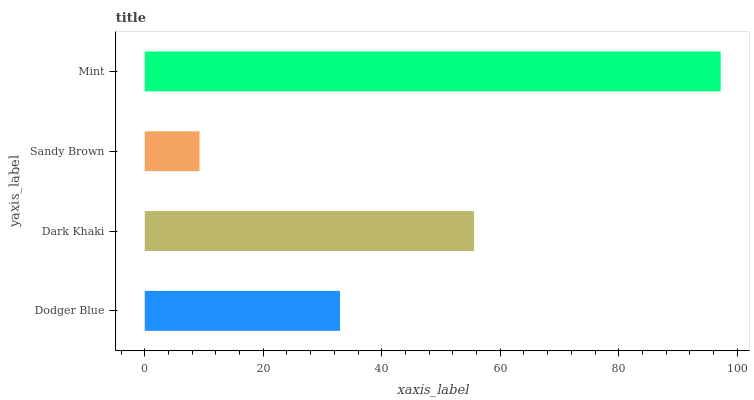Is Sandy Brown the minimum?
Answer yes or no. Yes. Is Mint the maximum?
Answer yes or no. Yes. Is Dark Khaki the minimum?
Answer yes or no. No. Is Dark Khaki the maximum?
Answer yes or no. No. Is Dark Khaki greater than Dodger Blue?
Answer yes or no. Yes. Is Dodger Blue less than Dark Khaki?
Answer yes or no. Yes. Is Dodger Blue greater than Dark Khaki?
Answer yes or no. No. Is Dark Khaki less than Dodger Blue?
Answer yes or no. No. Is Dark Khaki the high median?
Answer yes or no. Yes. Is Dodger Blue the low median?
Answer yes or no. Yes. Is Dodger Blue the high median?
Answer yes or no. No. Is Mint the low median?
Answer yes or no. No. 